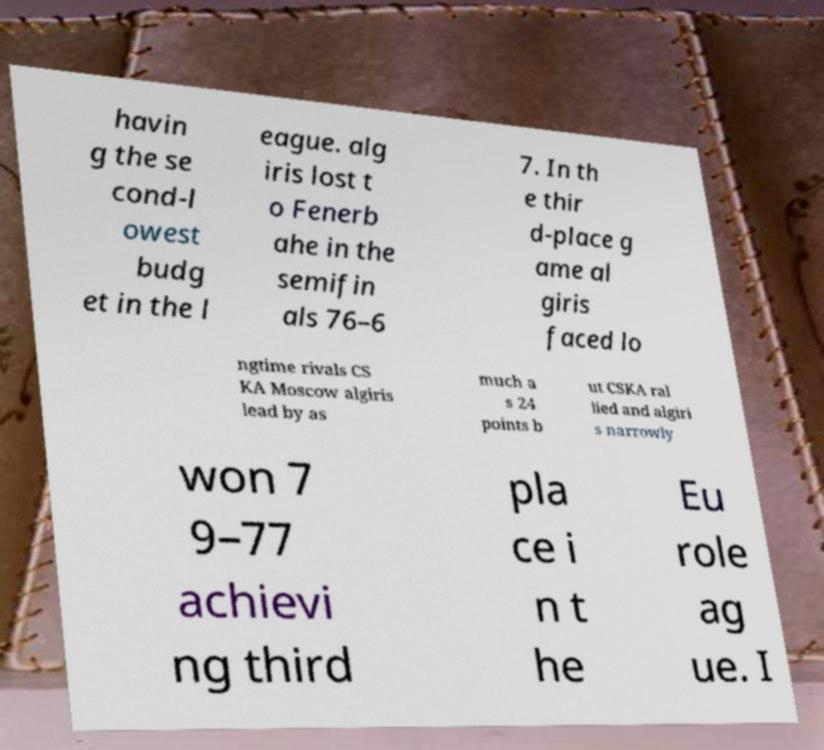For documentation purposes, I need the text within this image transcribed. Could you provide that? havin g the se cond-l owest budg et in the l eague. alg iris lost t o Fenerb ahe in the semifin als 76–6 7. In th e thir d-place g ame al giris faced lo ngtime rivals CS KA Moscow algiris lead by as much a s 24 points b ut CSKA ral lied and algiri s narrowly won 7 9–77 achievi ng third pla ce i n t he Eu role ag ue. I 